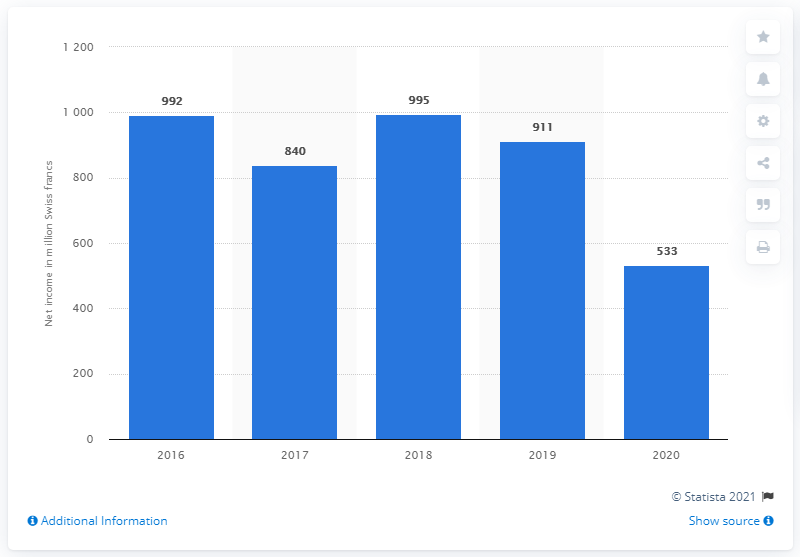Indicate a few pertinent items in this graphic. The net income of the Swatch Group in 2020 was 533 million. 